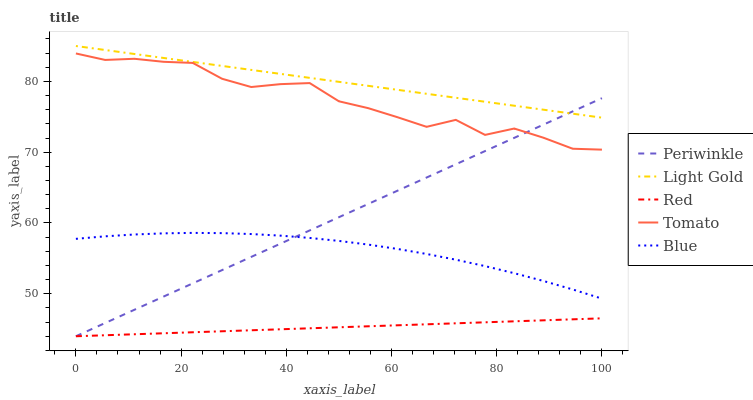Does Red have the minimum area under the curve?
Answer yes or no. Yes. Does Light Gold have the maximum area under the curve?
Answer yes or no. Yes. Does Periwinkle have the minimum area under the curve?
Answer yes or no. No. Does Periwinkle have the maximum area under the curve?
Answer yes or no. No. Is Red the smoothest?
Answer yes or no. Yes. Is Tomato the roughest?
Answer yes or no. Yes. Is Light Gold the smoothest?
Answer yes or no. No. Is Light Gold the roughest?
Answer yes or no. No. Does Periwinkle have the lowest value?
Answer yes or no. Yes. Does Light Gold have the lowest value?
Answer yes or no. No. Does Light Gold have the highest value?
Answer yes or no. Yes. Does Periwinkle have the highest value?
Answer yes or no. No. Is Red less than Light Gold?
Answer yes or no. Yes. Is Tomato greater than Blue?
Answer yes or no. Yes. Does Red intersect Periwinkle?
Answer yes or no. Yes. Is Red less than Periwinkle?
Answer yes or no. No. Is Red greater than Periwinkle?
Answer yes or no. No. Does Red intersect Light Gold?
Answer yes or no. No. 